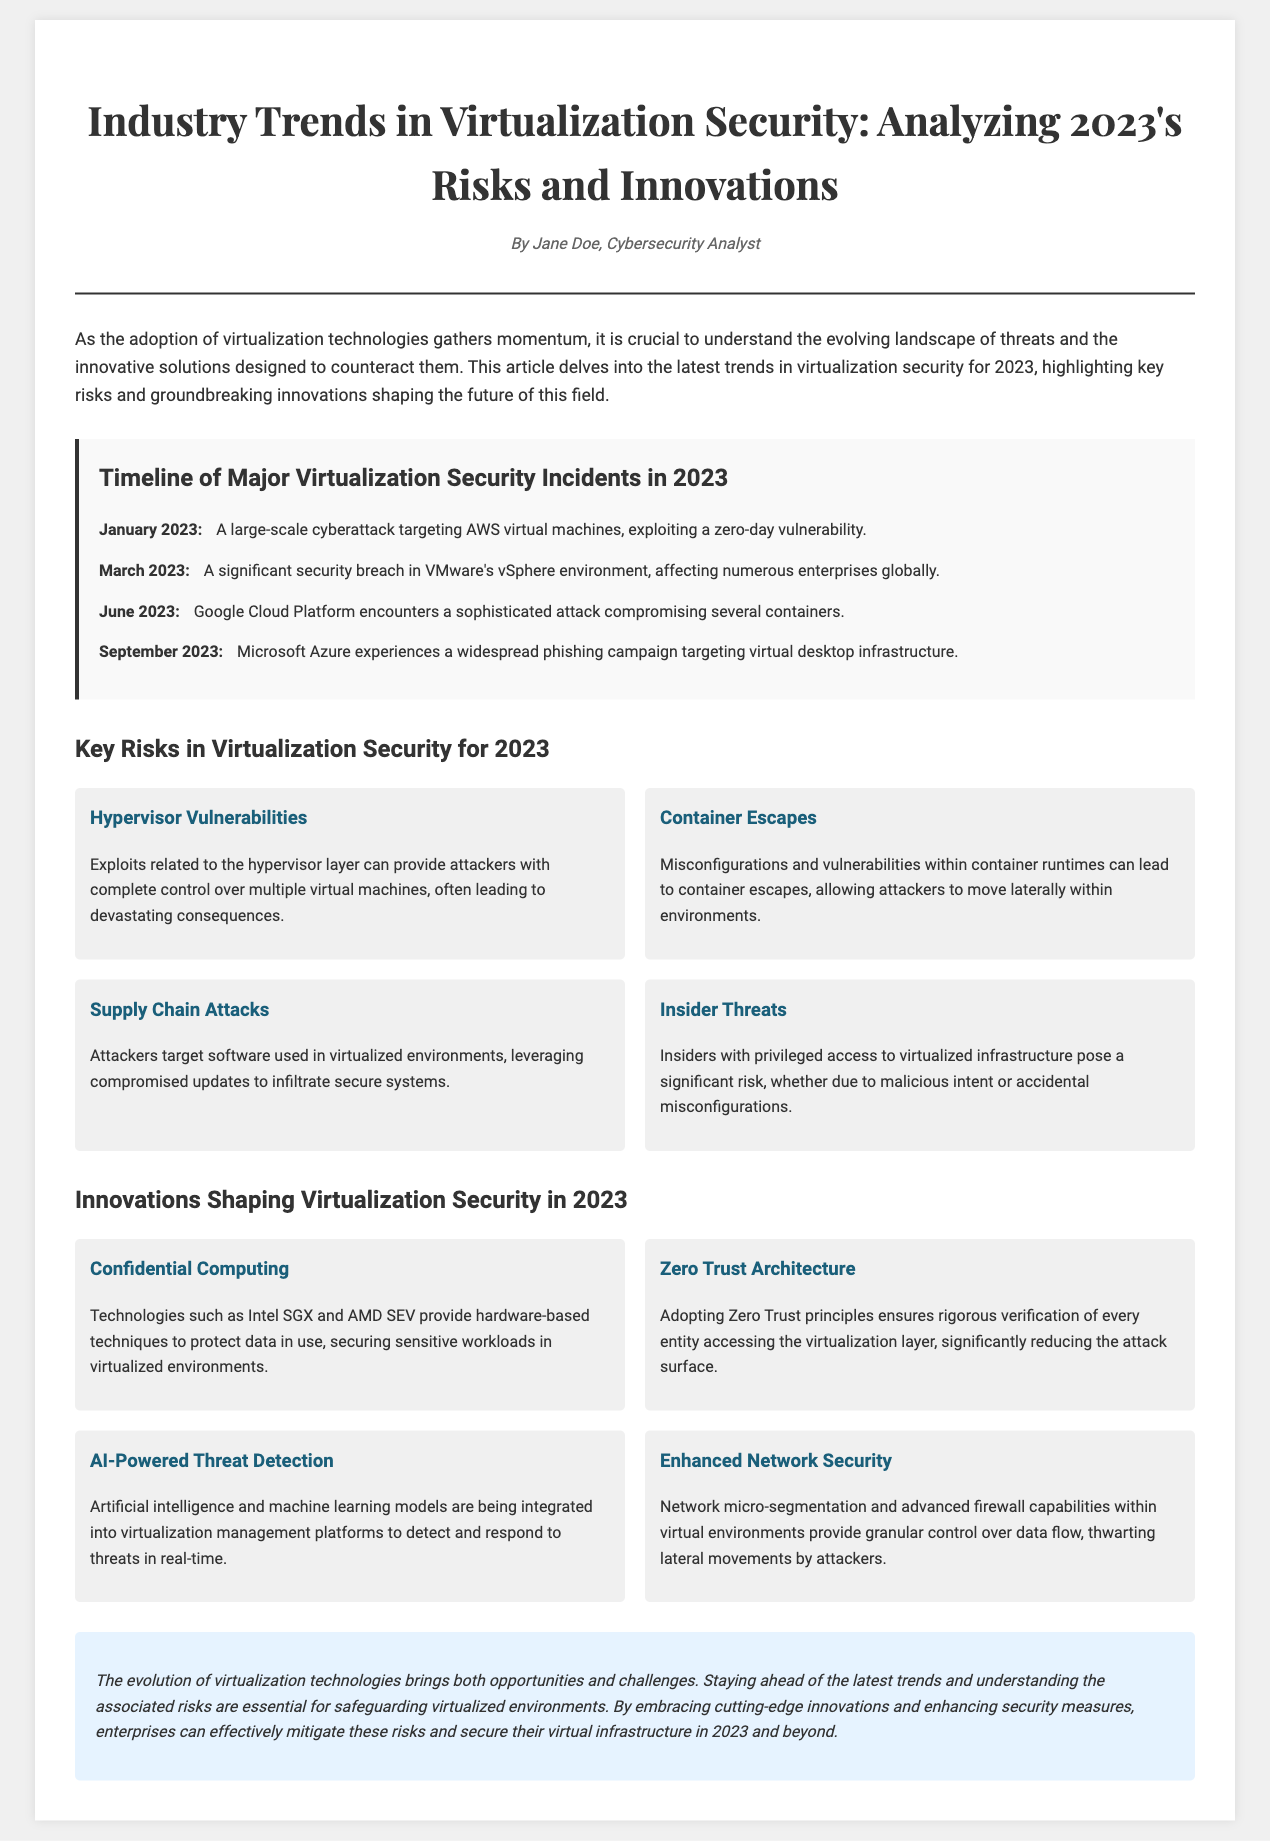What is the title of the article? The title of the article is stated at the top of the document and provides a summary of its content.
Answer: Industry Trends in Virtualization Security: Analyzing 2023's Risks and Innovations Who is the author of the article? The author of the article is mentioned in the header section, providing credit for the content.
Answer: Jane Doe What was the date of the cyberattack on AWS virtual machines? The timeline provides dates of significant incidents, and January 2023 is listed as the date of this specific event.
Answer: January 2023 How many key risks are identified in the document? The section covering risks lists a total of four specific risks in virtualization security for 2023.
Answer: Four What innovation involves protecting data in use? The innovation section describes various innovations, and one specifically mentions technologies for securing sensitive workloads.
Answer: Confidential Computing Which principle is emphasized in reducing the attack surface? The document discusses various innovations, and one emphasizes strict verification for access to the virtualization layer.
Answer: Zero Trust Architecture In which month did Microsoft Azure experience a phishing campaign? The timeline lists September 2023 as the date for the phishing campaign incident related to Microsoft Azure.
Answer: September 2023 What type of attack do insider threats represent? The document highlights risks, including one that specifies the nature of threats posed by individuals with privileged access.
Answer: Significant risk What protects against lateral movements by attackers? Innovations section covers solutions for enhancing network security and mentions a specific method to control data flow.
Answer: Network micro-segmentation 